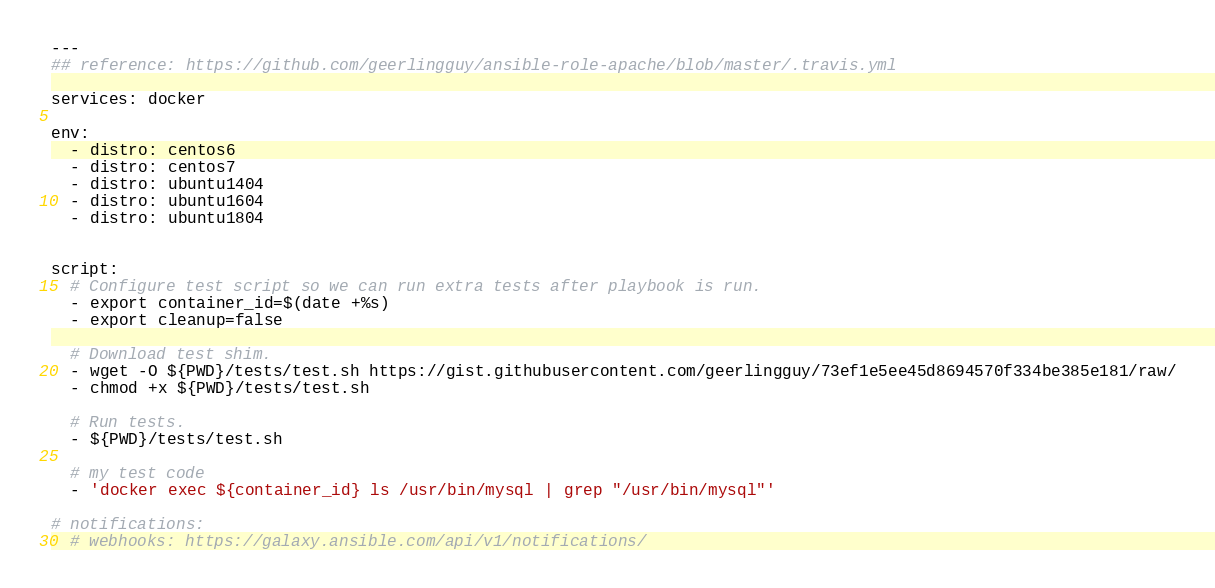<code> <loc_0><loc_0><loc_500><loc_500><_YAML_>---
## reference: https://github.com/geerlingguy/ansible-role-apache/blob/master/.travis.yml

services: docker

env:
  - distro: centos6
  - distro: centos7
  - distro: ubuntu1404
  - distro: ubuntu1604
  - distro: ubuntu1804


script:
  # Configure test script so we can run extra tests after playbook is run.
  - export container_id=$(date +%s)
  - export cleanup=false

  # Download test shim.
  - wget -O ${PWD}/tests/test.sh https://gist.githubusercontent.com/geerlingguy/73ef1e5ee45d8694570f334be385e181/raw/
  - chmod +x ${PWD}/tests/test.sh

  # Run tests.
  - ${PWD}/tests/test.sh

  # my test code
  - 'docker exec ${container_id} ls /usr/bin/mysql | grep "/usr/bin/mysql"'

# notifications:
  # webhooks: https://galaxy.ansible.com/api/v1/notifications/
</code> 